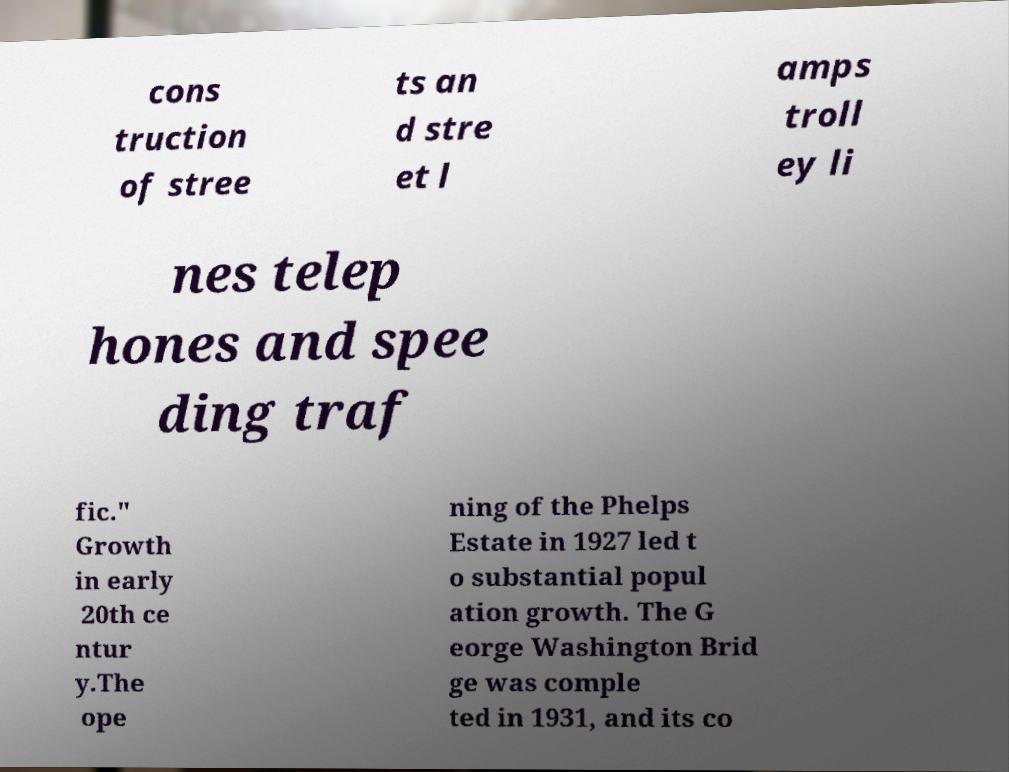Please read and relay the text visible in this image. What does it say? cons truction of stree ts an d stre et l amps troll ey li nes telep hones and spee ding traf fic." Growth in early 20th ce ntur y.The ope ning of the Phelps Estate in 1927 led t o substantial popul ation growth. The G eorge Washington Brid ge was comple ted in 1931, and its co 